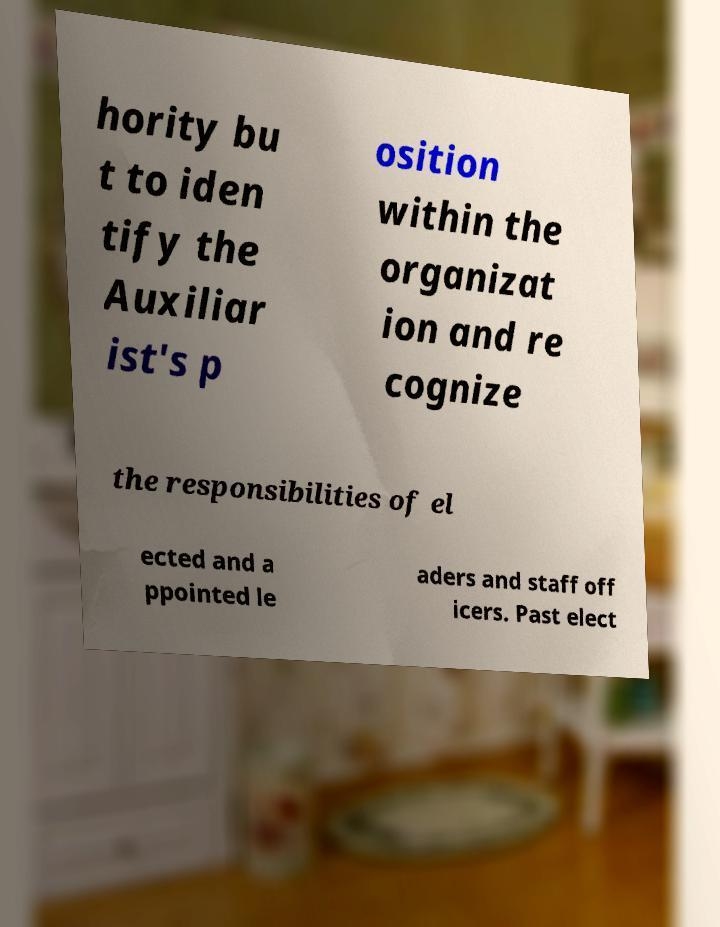Could you extract and type out the text from this image? hority bu t to iden tify the Auxiliar ist's p osition within the organizat ion and re cognize the responsibilities of el ected and a ppointed le aders and staff off icers. Past elect 